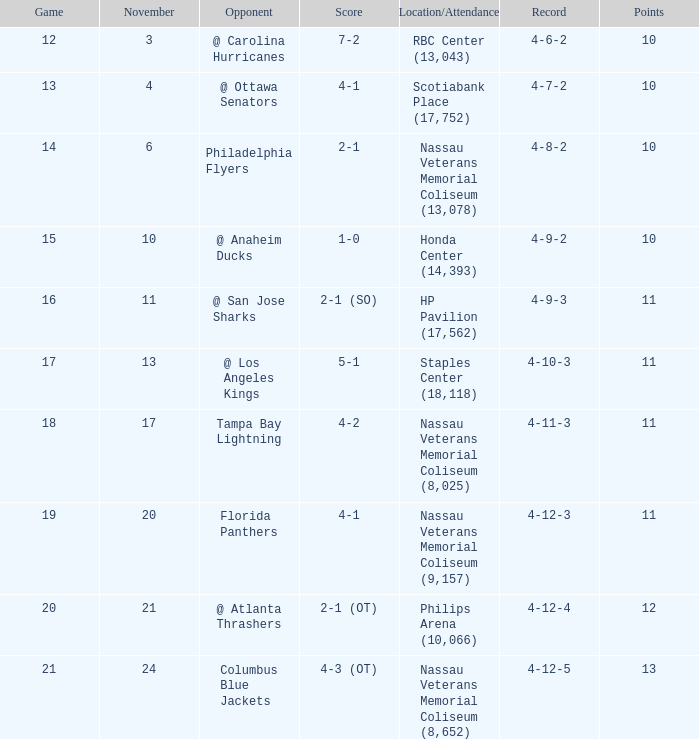What is the lowest entry point for a game where the score is 1-0? 15.0. 